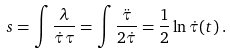<formula> <loc_0><loc_0><loc_500><loc_500>s = \int \frac { \lambda } { \dot { \tau } \tau } = \int \frac { \ddot { \tau } } { 2 \dot { \tau } } = \frac { 1 } { 2 } \ln \dot { \tau } ( t ) \, .</formula> 